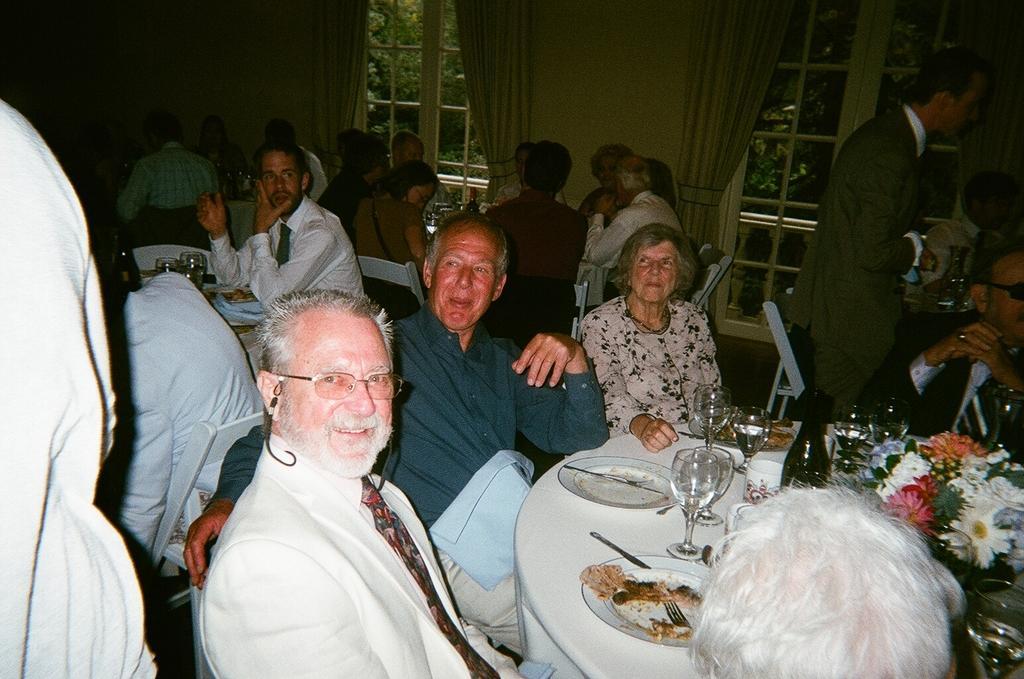Describe this image in one or two sentences. The picture is taken inside a room. There are many people sitting on chairs. On the dining table there are plates with food, fork ,spoon, glasses, bottles, bouquet. In the background there are glass windows through which we can see outside there are trees. There are curtains in the background. On the floor few people are standing. 